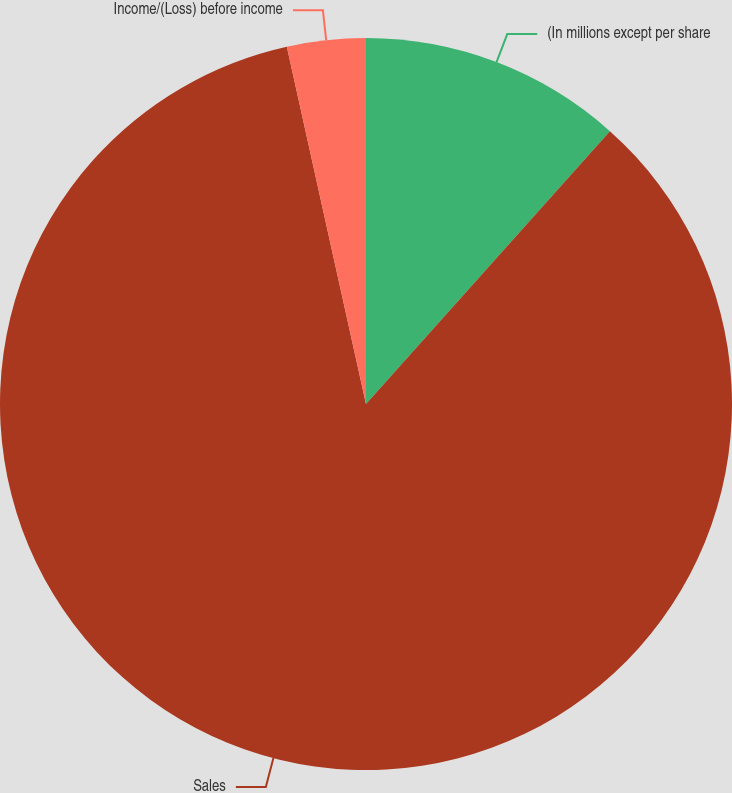<chart> <loc_0><loc_0><loc_500><loc_500><pie_chart><fcel>(In millions except per share<fcel>Sales<fcel>Income/(Loss) before income<nl><fcel>11.61%<fcel>84.92%<fcel>3.47%<nl></chart> 